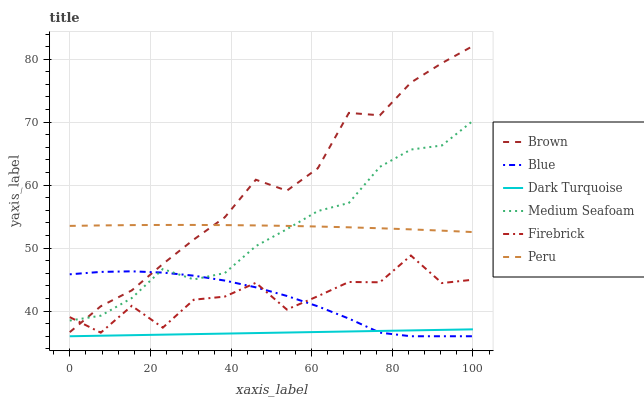Does Dark Turquoise have the minimum area under the curve?
Answer yes or no. Yes. Does Brown have the maximum area under the curve?
Answer yes or no. Yes. Does Brown have the minimum area under the curve?
Answer yes or no. No. Does Dark Turquoise have the maximum area under the curve?
Answer yes or no. No. Is Dark Turquoise the smoothest?
Answer yes or no. Yes. Is Firebrick the roughest?
Answer yes or no. Yes. Is Brown the smoothest?
Answer yes or no. No. Is Brown the roughest?
Answer yes or no. No. Does Brown have the lowest value?
Answer yes or no. No. Does Brown have the highest value?
Answer yes or no. Yes. Does Dark Turquoise have the highest value?
Answer yes or no. No. Is Firebrick less than Peru?
Answer yes or no. Yes. Is Peru greater than Dark Turquoise?
Answer yes or no. Yes. Does Brown intersect Medium Seafoam?
Answer yes or no. Yes. Is Brown less than Medium Seafoam?
Answer yes or no. No. Is Brown greater than Medium Seafoam?
Answer yes or no. No. Does Firebrick intersect Peru?
Answer yes or no. No. 